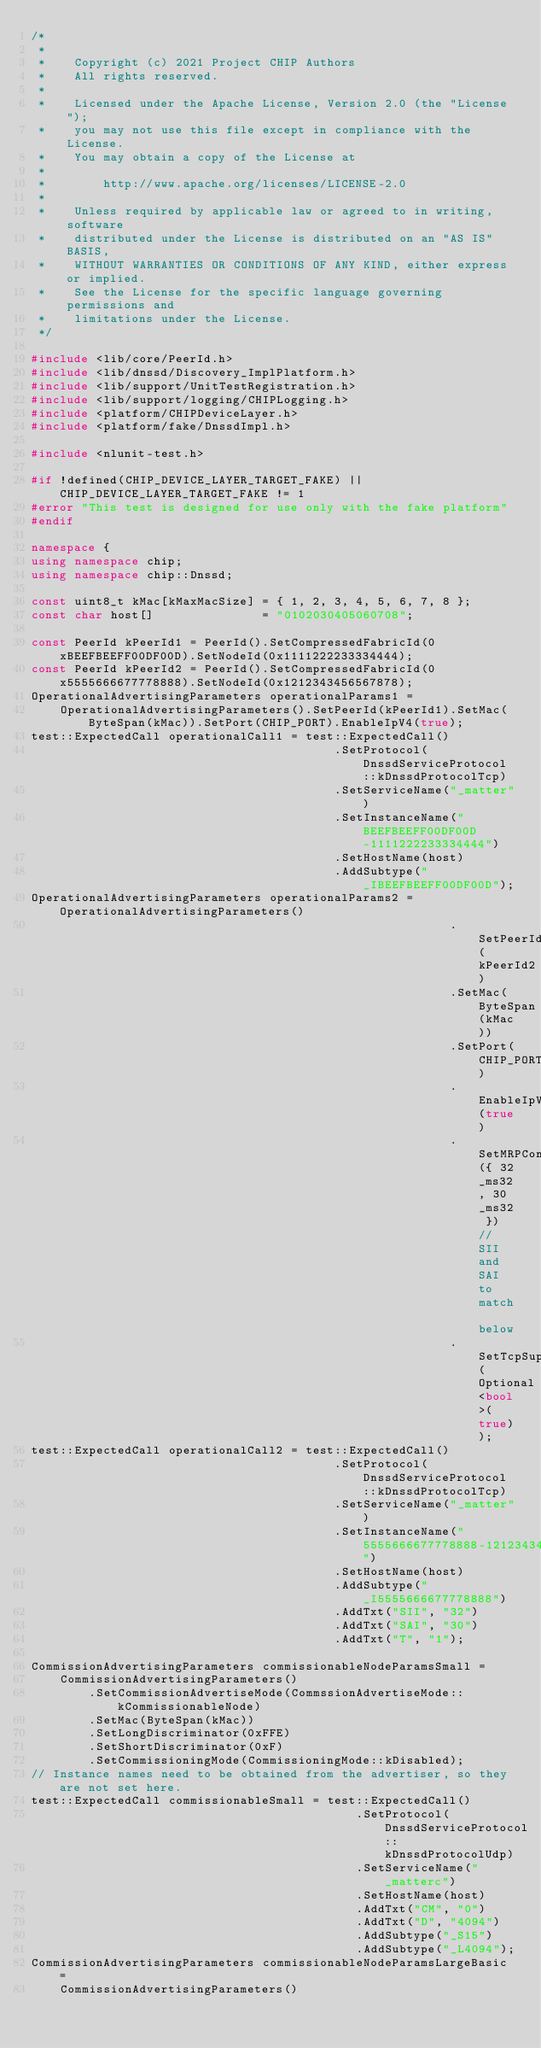Convert code to text. <code><loc_0><loc_0><loc_500><loc_500><_C++_>/*
 *
 *    Copyright (c) 2021 Project CHIP Authors
 *    All rights reserved.
 *
 *    Licensed under the Apache License, Version 2.0 (the "License");
 *    you may not use this file except in compliance with the License.
 *    You may obtain a copy of the License at
 *
 *        http://www.apache.org/licenses/LICENSE-2.0
 *
 *    Unless required by applicable law or agreed to in writing, software
 *    distributed under the License is distributed on an "AS IS" BASIS,
 *    WITHOUT WARRANTIES OR CONDITIONS OF ANY KIND, either express or implied.
 *    See the License for the specific language governing permissions and
 *    limitations under the License.
 */

#include <lib/core/PeerId.h>
#include <lib/dnssd/Discovery_ImplPlatform.h>
#include <lib/support/UnitTestRegistration.h>
#include <lib/support/logging/CHIPLogging.h>
#include <platform/CHIPDeviceLayer.h>
#include <platform/fake/DnssdImpl.h>

#include <nlunit-test.h>

#if !defined(CHIP_DEVICE_LAYER_TARGET_FAKE) || CHIP_DEVICE_LAYER_TARGET_FAKE != 1
#error "This test is designed for use only with the fake platform"
#endif

namespace {
using namespace chip;
using namespace chip::Dnssd;

const uint8_t kMac[kMaxMacSize] = { 1, 2, 3, 4, 5, 6, 7, 8 };
const char host[]               = "0102030405060708";

const PeerId kPeerId1 = PeerId().SetCompressedFabricId(0xBEEFBEEFF00DF00D).SetNodeId(0x1111222233334444);
const PeerId kPeerId2 = PeerId().SetCompressedFabricId(0x5555666677778888).SetNodeId(0x1212343456567878);
OperationalAdvertisingParameters operationalParams1 =
    OperationalAdvertisingParameters().SetPeerId(kPeerId1).SetMac(ByteSpan(kMac)).SetPort(CHIP_PORT).EnableIpV4(true);
test::ExpectedCall operationalCall1 = test::ExpectedCall()
                                          .SetProtocol(DnssdServiceProtocol::kDnssdProtocolTcp)
                                          .SetServiceName("_matter")
                                          .SetInstanceName("BEEFBEEFF00DF00D-1111222233334444")
                                          .SetHostName(host)
                                          .AddSubtype("_IBEEFBEEFF00DF00D");
OperationalAdvertisingParameters operationalParams2 = OperationalAdvertisingParameters()
                                                          .SetPeerId(kPeerId2)
                                                          .SetMac(ByteSpan(kMac))
                                                          .SetPort(CHIP_PORT)
                                                          .EnableIpV4(true)
                                                          .SetMRPConfig({ 32_ms32, 30_ms32 }) // SII and SAI to match below
                                                          .SetTcpSupported(Optional<bool>(true));
test::ExpectedCall operationalCall2 = test::ExpectedCall()
                                          .SetProtocol(DnssdServiceProtocol::kDnssdProtocolTcp)
                                          .SetServiceName("_matter")
                                          .SetInstanceName("5555666677778888-1212343456567878")
                                          .SetHostName(host)
                                          .AddSubtype("_I5555666677778888")
                                          .AddTxt("SII", "32")
                                          .AddTxt("SAI", "30")
                                          .AddTxt("T", "1");

CommissionAdvertisingParameters commissionableNodeParamsSmall =
    CommissionAdvertisingParameters()
        .SetCommissionAdvertiseMode(CommssionAdvertiseMode::kCommissionableNode)
        .SetMac(ByteSpan(kMac))
        .SetLongDiscriminator(0xFFE)
        .SetShortDiscriminator(0xF)
        .SetCommissioningMode(CommissioningMode::kDisabled);
// Instance names need to be obtained from the advertiser, so they are not set here.
test::ExpectedCall commissionableSmall = test::ExpectedCall()
                                             .SetProtocol(DnssdServiceProtocol::kDnssdProtocolUdp)
                                             .SetServiceName("_matterc")
                                             .SetHostName(host)
                                             .AddTxt("CM", "0")
                                             .AddTxt("D", "4094")
                                             .AddSubtype("_S15")
                                             .AddSubtype("_L4094");
CommissionAdvertisingParameters commissionableNodeParamsLargeBasic =
    CommissionAdvertisingParameters()</code> 